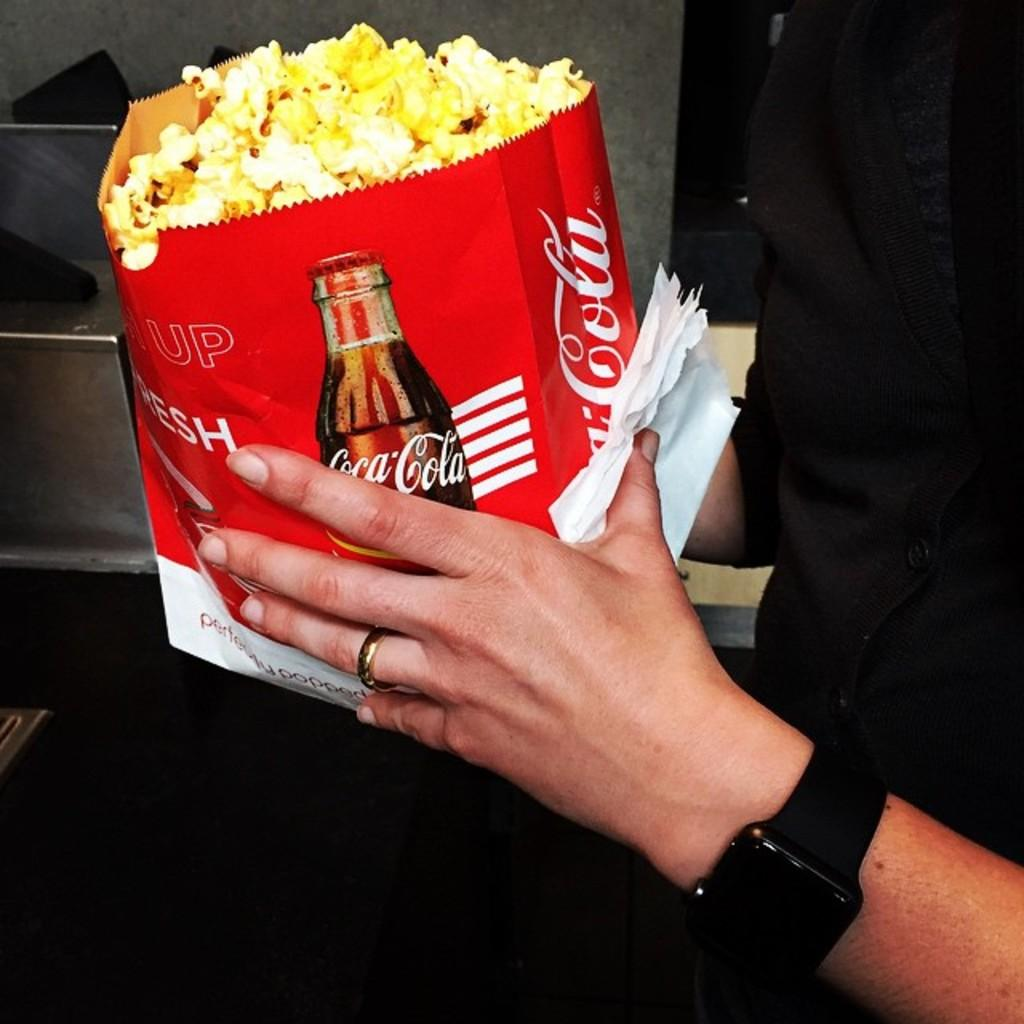<image>
Describe the image concisely. A bag of popcorn with a picture of a Coca Cola bottle on the side of the bag. 